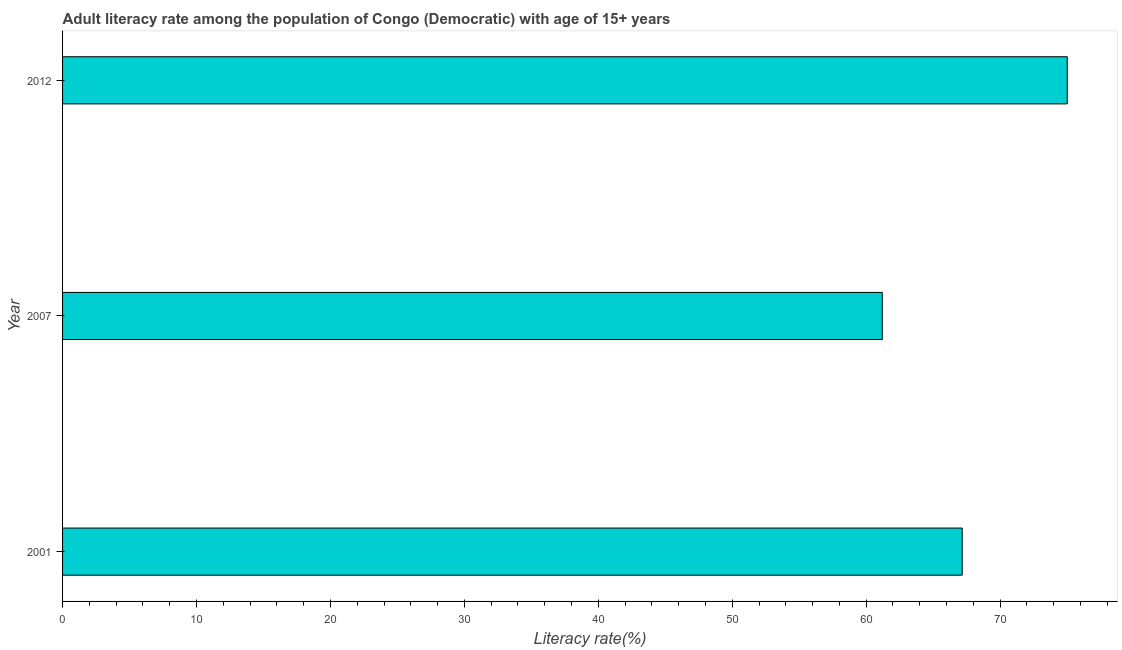Does the graph contain any zero values?
Offer a very short reply. No. Does the graph contain grids?
Provide a succinct answer. No. What is the title of the graph?
Give a very brief answer. Adult literacy rate among the population of Congo (Democratic) with age of 15+ years. What is the label or title of the X-axis?
Provide a succinct answer. Literacy rate(%). What is the label or title of the Y-axis?
Keep it short and to the point. Year. What is the adult literacy rate in 2007?
Ensure brevity in your answer.  61.21. Across all years, what is the maximum adult literacy rate?
Provide a short and direct response. 75.02. Across all years, what is the minimum adult literacy rate?
Ensure brevity in your answer.  61.21. What is the sum of the adult literacy rate?
Your response must be concise. 203.4. What is the difference between the adult literacy rate in 2001 and 2007?
Provide a succinct answer. 5.97. What is the average adult literacy rate per year?
Provide a succinct answer. 67.8. What is the median adult literacy rate?
Your answer should be compact. 67.17. In how many years, is the adult literacy rate greater than 12 %?
Keep it short and to the point. 3. Do a majority of the years between 2001 and 2007 (inclusive) have adult literacy rate greater than 50 %?
Offer a terse response. Yes. What is the ratio of the adult literacy rate in 2001 to that in 2007?
Offer a terse response. 1.1. Is the adult literacy rate in 2001 less than that in 2012?
Provide a succinct answer. Yes. Is the difference between the adult literacy rate in 2001 and 2007 greater than the difference between any two years?
Your answer should be very brief. No. What is the difference between the highest and the second highest adult literacy rate?
Keep it short and to the point. 7.84. Is the sum of the adult literacy rate in 2001 and 2012 greater than the maximum adult literacy rate across all years?
Offer a terse response. Yes. What is the difference between the highest and the lowest adult literacy rate?
Ensure brevity in your answer.  13.81. How many bars are there?
Provide a succinct answer. 3. How many years are there in the graph?
Your answer should be compact. 3. Are the values on the major ticks of X-axis written in scientific E-notation?
Offer a very short reply. No. What is the Literacy rate(%) of 2001?
Your response must be concise. 67.17. What is the Literacy rate(%) of 2007?
Give a very brief answer. 61.21. What is the Literacy rate(%) in 2012?
Ensure brevity in your answer.  75.02. What is the difference between the Literacy rate(%) in 2001 and 2007?
Your response must be concise. 5.97. What is the difference between the Literacy rate(%) in 2001 and 2012?
Provide a succinct answer. -7.84. What is the difference between the Literacy rate(%) in 2007 and 2012?
Keep it short and to the point. -13.81. What is the ratio of the Literacy rate(%) in 2001 to that in 2007?
Your response must be concise. 1.1. What is the ratio of the Literacy rate(%) in 2001 to that in 2012?
Make the answer very short. 0.9. What is the ratio of the Literacy rate(%) in 2007 to that in 2012?
Offer a terse response. 0.82. 